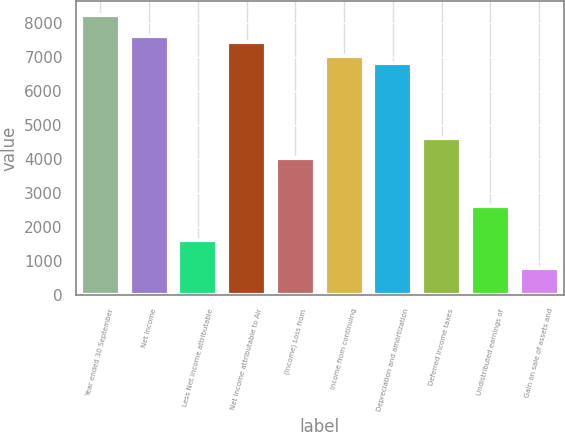<chart> <loc_0><loc_0><loc_500><loc_500><bar_chart><fcel>Year ended 30 September<fcel>Net Income<fcel>Less Net income attributable<fcel>Net income attributable to Air<fcel>(Income) Loss from<fcel>Income from continuing<fcel>Depreciation and amortization<fcel>Deferred income taxes<fcel>Undistributed earnings of<fcel>Gain on sale of assets and<nl><fcel>8243.55<fcel>7640.4<fcel>1608.9<fcel>7439.35<fcel>4021.5<fcel>7037.25<fcel>6836.2<fcel>4624.65<fcel>2614.15<fcel>804.7<nl></chart> 